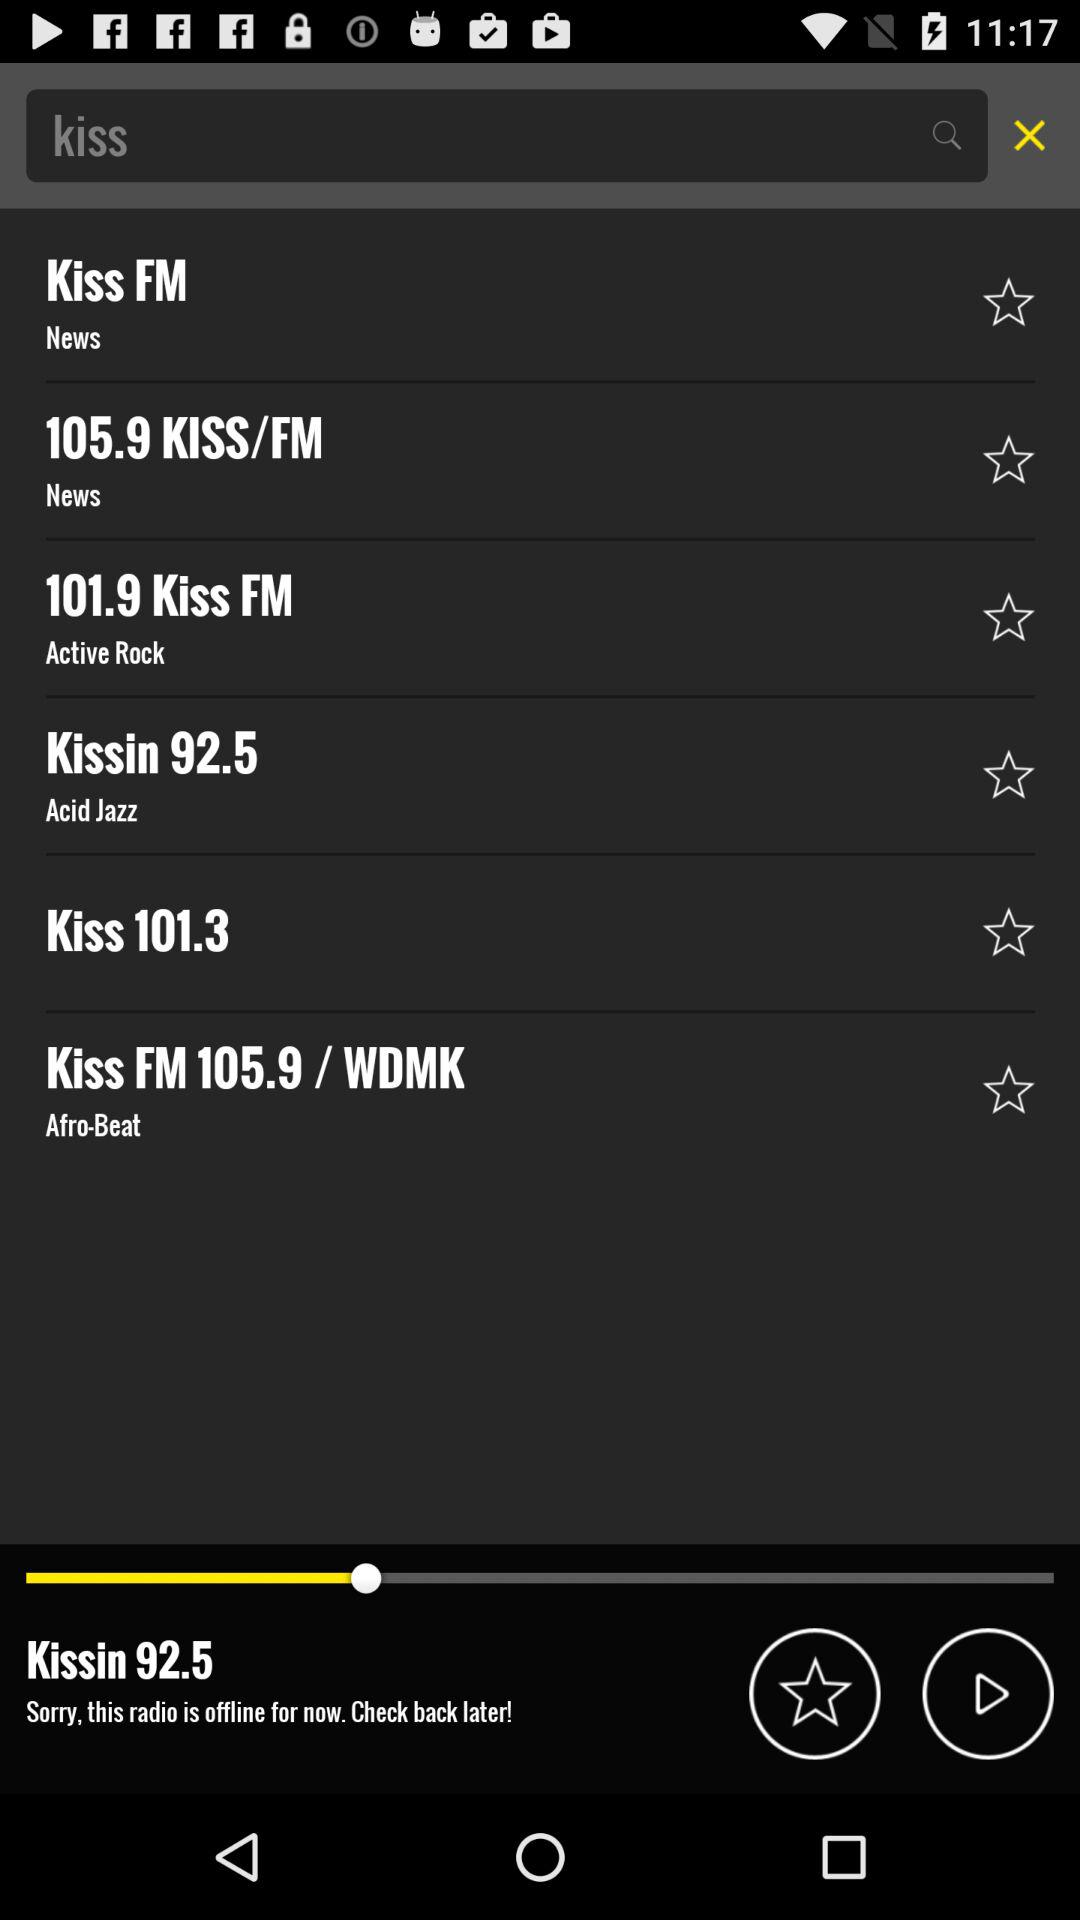How many of the radio stations have the genre 'Acid Jazz'?
Answer the question using a single word or phrase. 1 